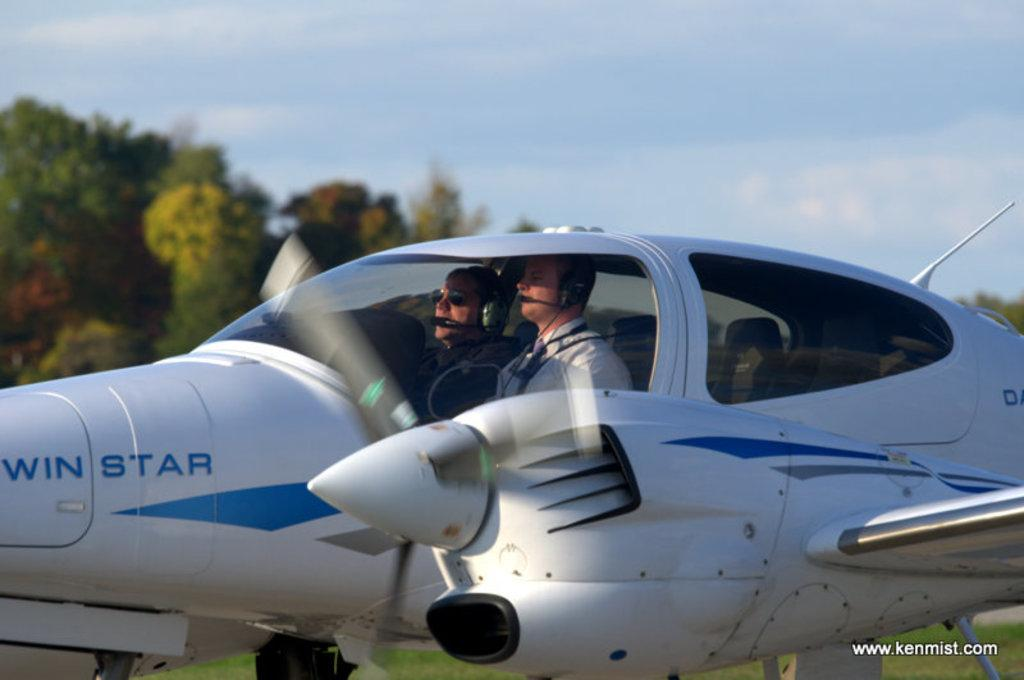What is the main subject of the image? The main subject of the image is an airplane. What features can be observed on the airplane? The airplane has wheels, wings, and a propeller. How many people are inside the airplane? There are two persons sitting in the airplane. What can be seen on the left side of the image? There are trees on the left side of the image. What is visible at the top of the image? The sky is visible at the top of the image. What type of dinner is being served in the airplane? There is no dinner being served in the image; it only shows an airplane with two persons inside. Can you tell me how the airplane is blowing air in the image? The airplane does not appear to be blowing air in the image; it is stationary on the ground or in the air. 